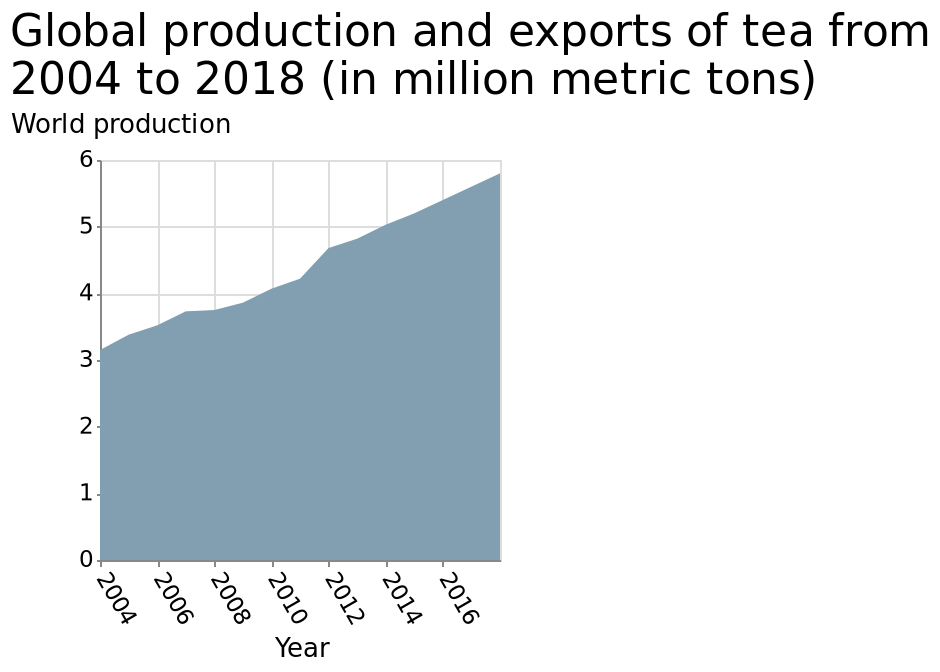<image>
What is the unit of measurement for the production and exports of tea? The unit of measurement for the production and exports of tea is million metric tons. What is the range of the y-axis on the area diagram?  The range of the y-axis on the area diagram is from 0 to 6 million metric tons. Offer a thorough analysis of the image. The world is rapidly increasing its production of tea. 